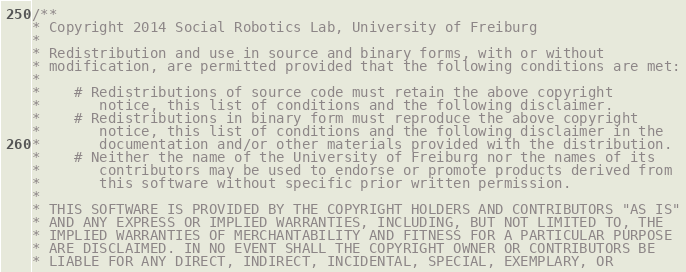Convert code to text. <code><loc_0><loc_0><loc_500><loc_500><_C_>/**
* Copyright 2014 Social Robotics Lab, University of Freiburg
*
* Redistribution and use in source and binary forms, with or without
* modification, are permitted provided that the following conditions are met:
*
*    # Redistributions of source code must retain the above copyright
*       notice, this list of conditions and the following disclaimer.
*    # Redistributions in binary form must reproduce the above copyright
*       notice, this list of conditions and the following disclaimer in the
*       documentation and/or other materials provided with the distribution.
*    # Neither the name of the University of Freiburg nor the names of its
*       contributors may be used to endorse or promote products derived from
*       this software without specific prior written permission.
*
* THIS SOFTWARE IS PROVIDED BY THE COPYRIGHT HOLDERS AND CONTRIBUTORS "AS IS"
* AND ANY EXPRESS OR IMPLIED WARRANTIES, INCLUDING, BUT NOT LIMITED TO, THE
* IMPLIED WARRANTIES OF MERCHANTABILITY AND FITNESS FOR A PARTICULAR PURPOSE
* ARE DISCLAIMED. IN NO EVENT SHALL THE COPYRIGHT OWNER OR CONTRIBUTORS BE
* LIABLE FOR ANY DIRECT, INDIRECT, INCIDENTAL, SPECIAL, EXEMPLARY, OR</code> 